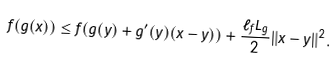<formula> <loc_0><loc_0><loc_500><loc_500>f ( g ( x ) ) \leq f ( g ( y ) + g ^ { \prime } ( y ) ( x - y ) ) + \frac { \ell _ { f } L _ { g } } { 2 } \| x - y \| ^ { 2 } .</formula> 